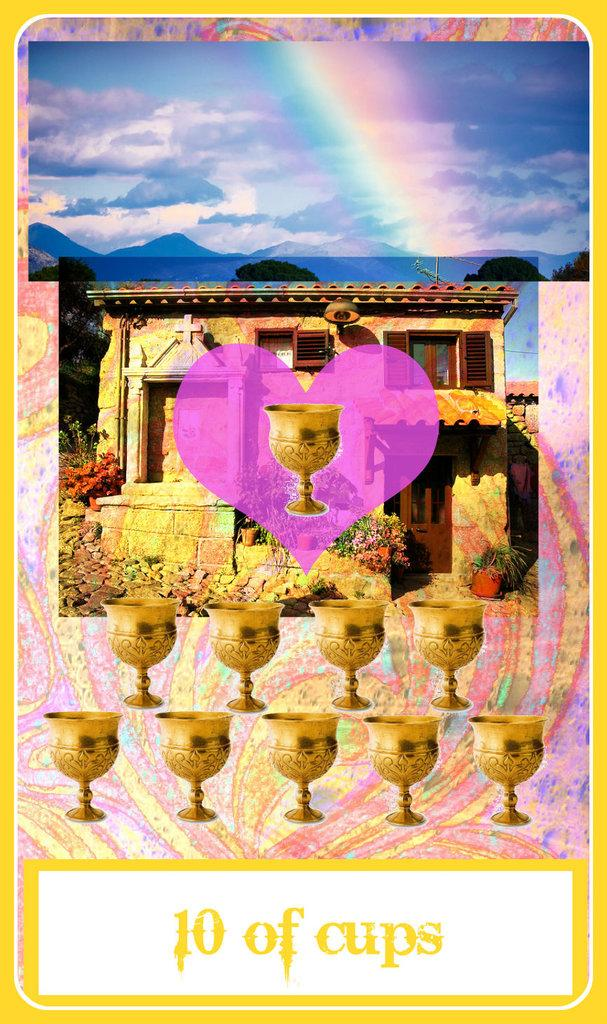What type of image is featured in the picture? There is an animated image in the picture. What objects can be seen in the animated image? There are golden cups and a building in the animated image. Are there any natural elements in the animated image? Yes, there are flowers in the animated image. How would you describe the weather in the animated image? The sky in the animated image is cloudy. What type of sign can be seen in the image? There is no sign present in the image; it features an animated scene with golden cups, a building, flowers, and a cloudy sky. What type of sticks are used to create the flowers in the image? There are no sticks used to create the flowers in the image; the flowers are part of the animated scene. 